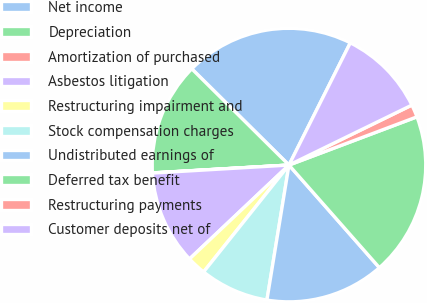<chart> <loc_0><loc_0><loc_500><loc_500><pie_chart><fcel>Net income<fcel>Depreciation<fcel>Amortization of purchased<fcel>Asbestos litigation<fcel>Restructuring impairment and<fcel>Stock compensation charges<fcel>Undistributed earnings of<fcel>Deferred tax benefit<fcel>Restructuring payments<fcel>Customer deposits net of<nl><fcel>19.98%<fcel>13.33%<fcel>0.02%<fcel>11.11%<fcel>2.23%<fcel>8.15%<fcel>14.07%<fcel>19.24%<fcel>1.49%<fcel>10.37%<nl></chart> 